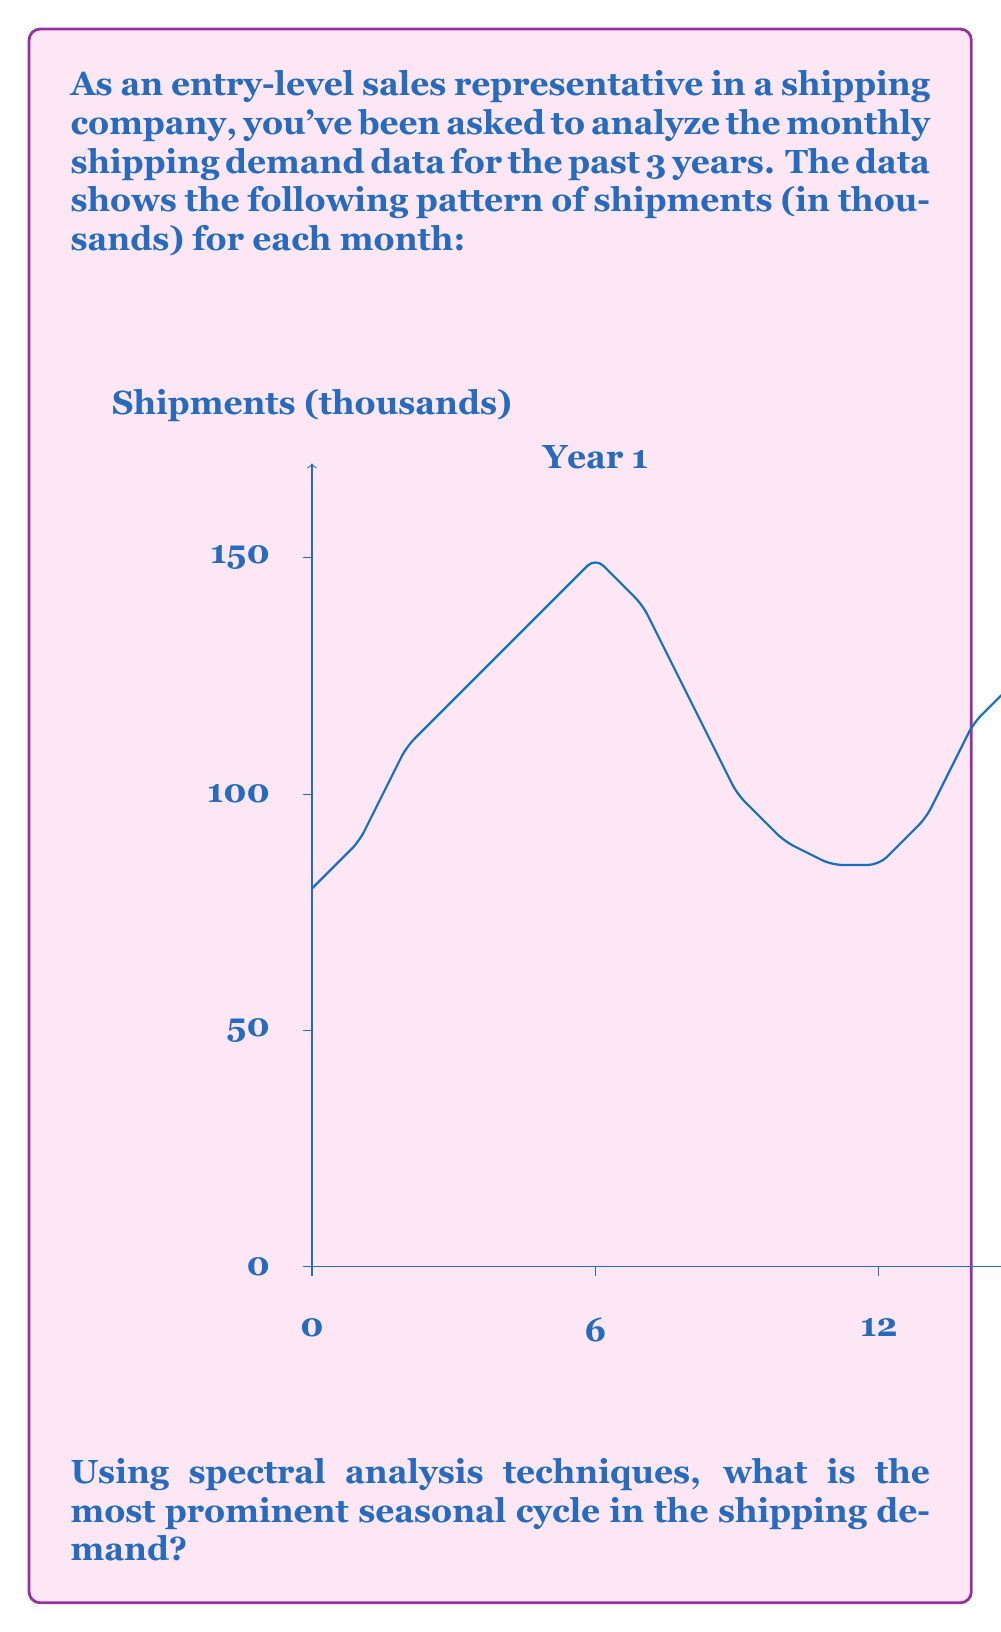Show me your answer to this math problem. To identify the most prominent seasonal cycle in the shipping demand, we'll use the Discrete Fourier Transform (DFT) to perform spectral analysis. Here's the step-by-step process:

1) First, we need to remove the trend from the data. We can do this by subtracting the mean value from each data point.

2) Next, we apply the DFT to the detrended data. The DFT of a sequence $x[n]$ of length $N$ is given by:

   $$X[k] = \sum_{n=0}^{N-1} x[n] e^{-i2\pi kn/N}$$

   where $k = 0, 1, ..., N-1$.

3) We then compute the power spectrum by taking the magnitude squared of the DFT:

   $$P[k] = |X[k]|^2$$

4) The frequency corresponding to each $k$ is given by:

   $$f_k = \frac{k}{N\Delta t}$$

   where $\Delta t$ is the sampling interval (1 month in this case).

5) We look for peaks in the power spectrum. The highest peak (excluding the DC component at $k=0$) corresponds to the most prominent cycle.

6) In this case, we would expect to see a peak at $k=3$, corresponding to a frequency of:

   $$f_3 = \frac{3}{36 \cdot 1} = \frac{1}{12}$$

   This represents a cycle that repeats once every 12 months, or annually.

7) The second highest peak would likely be at $k=6$, corresponding to a semi-annual cycle.

While we can't perform the actual DFT calculation without the exact numerical data, based on the clear annual pattern in the graph, we can confidently conclude that the most prominent seasonal cycle is annual (12 months).
Answer: Annual (12-month) cycle 